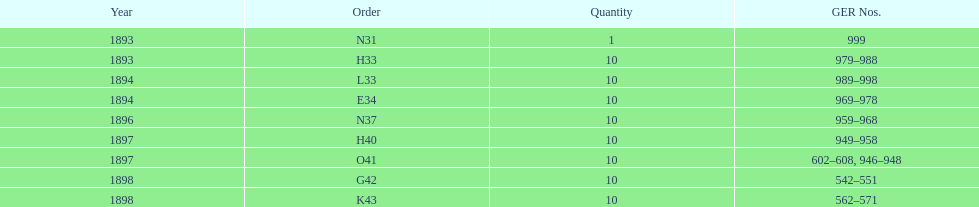What is the amount of years with a volume of 10? 5. I'm looking to parse the entire table for insights. Could you assist me with that? {'header': ['Year', 'Order', 'Quantity', 'GER Nos.'], 'rows': [['1893', 'N31', '1', '999'], ['1893', 'H33', '10', '979–988'], ['1894', 'L33', '10', '989–998'], ['1894', 'E34', '10', '969–978'], ['1896', 'N37', '10', '959–968'], ['1897', 'H40', '10', '949–958'], ['1897', 'O41', '10', '602–608, 946–948'], ['1898', 'G42', '10', '542–551'], ['1898', 'K43', '10', '562–571']]} 